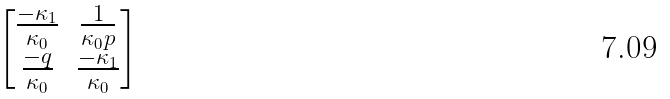<formula> <loc_0><loc_0><loc_500><loc_500>\begin{bmatrix} \frac { - \kappa _ { 1 } } { \kappa _ { 0 } } & \frac { 1 } { \kappa _ { 0 } p } \\ \frac { - q } { \kappa _ { 0 } } & \frac { - \kappa _ { 1 } } { \kappa _ { 0 } } \end{bmatrix}</formula> 